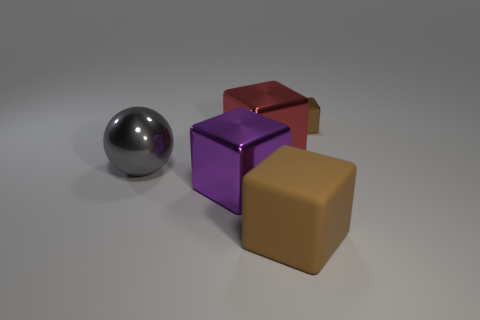Add 4 gray metallic things. How many objects exist? 9 Subtract all cubes. How many objects are left? 1 Subtract all big shiny spheres. Subtract all tiny objects. How many objects are left? 3 Add 1 big red metallic objects. How many big red metallic objects are left? 2 Add 4 blue metallic cylinders. How many blue metallic cylinders exist? 4 Subtract 0 cyan spheres. How many objects are left? 5 